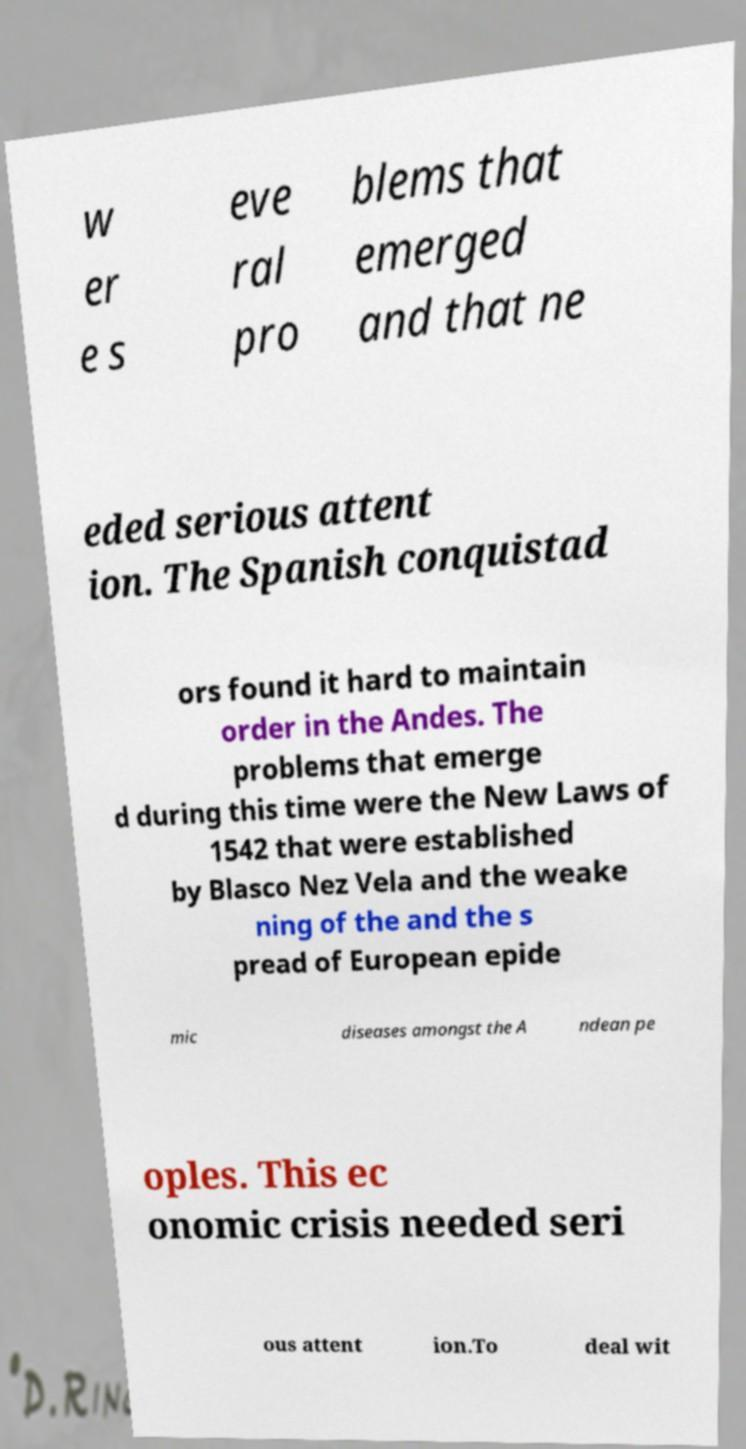Can you accurately transcribe the text from the provided image for me? w er e s eve ral pro blems that emerged and that ne eded serious attent ion. The Spanish conquistad ors found it hard to maintain order in the Andes. The problems that emerge d during this time were the New Laws of 1542 that were established by Blasco Nez Vela and the weake ning of the and the s pread of European epide mic diseases amongst the A ndean pe oples. This ec onomic crisis needed seri ous attent ion.To deal wit 